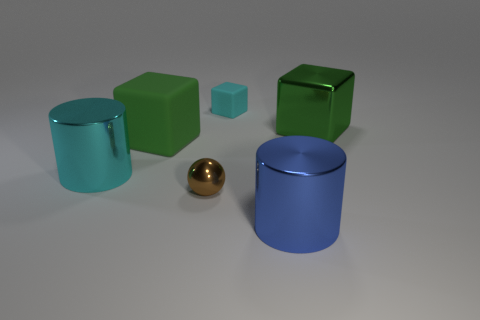Do the cylinder right of the big cyan shiny cylinder and the big cyan thing have the same material?
Your answer should be compact. Yes. The brown thing that is the same size as the cyan rubber cube is what shape?
Offer a terse response. Sphere. What number of shiny cubes are the same color as the big rubber object?
Provide a short and direct response. 1. Are there fewer large metal cylinders that are to the left of the small cyan thing than tiny brown spheres right of the large green matte block?
Offer a terse response. No. There is a blue cylinder; are there any cyan metal cylinders left of it?
Your answer should be compact. Yes. There is a large metal thing that is in front of the cyan thing in front of the shiny cube; is there a big cylinder that is behind it?
Make the answer very short. Yes. Does the matte object to the left of the tiny cyan block have the same shape as the large blue metal thing?
Ensure brevity in your answer.  No. There is another large cylinder that is the same material as the big blue cylinder; what is its color?
Your answer should be very brief. Cyan. How many cyan cylinders have the same material as the blue cylinder?
Give a very brief answer. 1. What is the color of the matte object that is in front of the green cube that is right of the tiny rubber object behind the tiny brown metallic thing?
Offer a terse response. Green. 